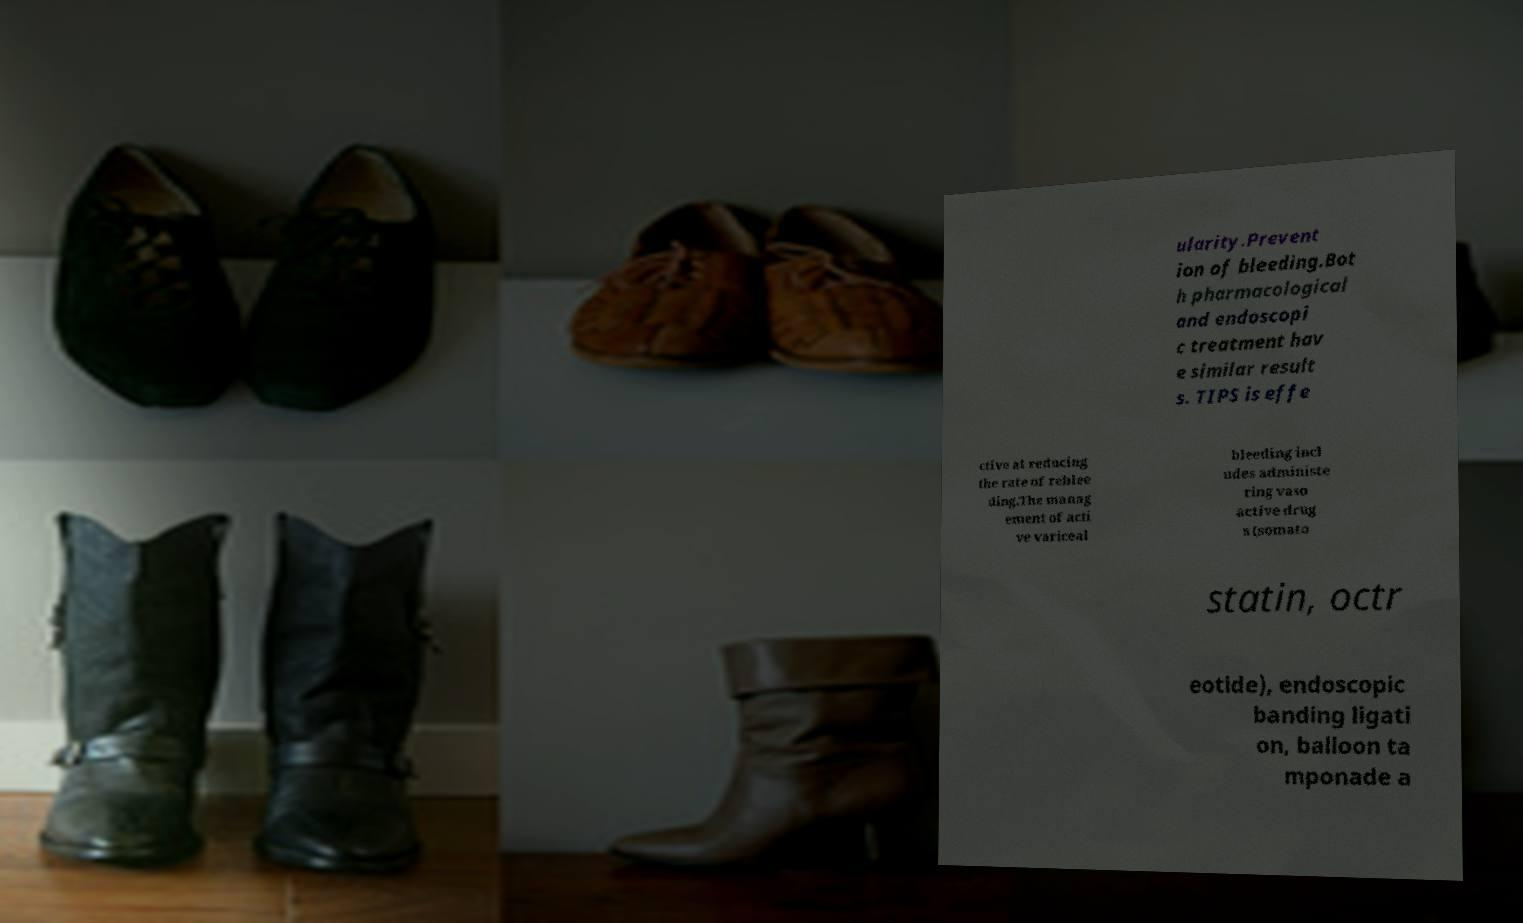Please identify and transcribe the text found in this image. ularity.Prevent ion of bleeding.Bot h pharmacological and endoscopi c treatment hav e similar result s. TIPS is effe ctive at reducing the rate of reblee ding.The manag ement of acti ve variceal bleeding incl udes administe ring vaso active drug s (somato statin, octr eotide), endoscopic banding ligati on, balloon ta mponade a 